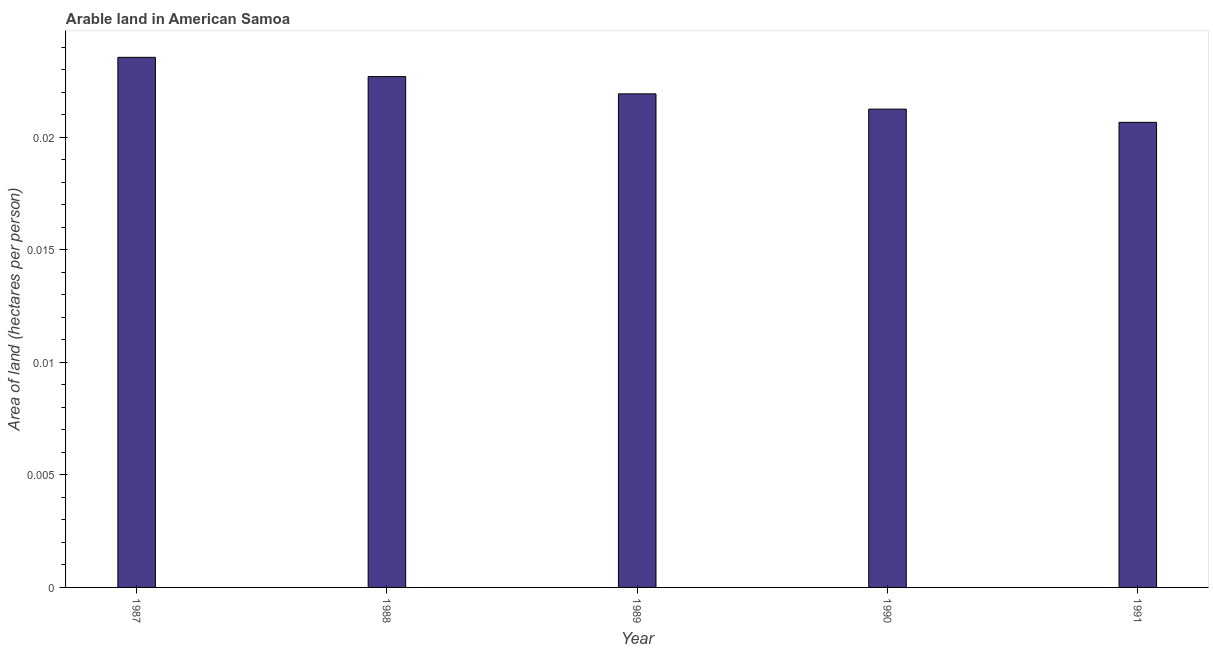What is the title of the graph?
Your answer should be very brief. Arable land in American Samoa. What is the label or title of the Y-axis?
Ensure brevity in your answer.  Area of land (hectares per person). What is the area of arable land in 1987?
Provide a short and direct response. 0.02. Across all years, what is the maximum area of arable land?
Offer a very short reply. 0.02. Across all years, what is the minimum area of arable land?
Give a very brief answer. 0.02. In which year was the area of arable land maximum?
Give a very brief answer. 1987. What is the sum of the area of arable land?
Give a very brief answer. 0.11. What is the average area of arable land per year?
Make the answer very short. 0.02. What is the median area of arable land?
Keep it short and to the point. 0.02. In how many years, is the area of arable land greater than 0.003 hectares per person?
Ensure brevity in your answer.  5. Do a majority of the years between 1987 and 1988 (inclusive) have area of arable land greater than 0.004 hectares per person?
Offer a terse response. Yes. What is the ratio of the area of arable land in 1987 to that in 1988?
Provide a short and direct response. 1.04. Is the area of arable land in 1989 less than that in 1991?
Offer a terse response. No. Is the difference between the area of arable land in 1988 and 1989 greater than the difference between any two years?
Give a very brief answer. No. What is the difference between the highest and the lowest area of arable land?
Provide a succinct answer. 0. How many bars are there?
Offer a very short reply. 5. Are all the bars in the graph horizontal?
Your response must be concise. No. How many years are there in the graph?
Offer a terse response. 5. What is the difference between two consecutive major ticks on the Y-axis?
Your response must be concise. 0.01. What is the Area of land (hectares per person) of 1987?
Keep it short and to the point. 0.02. What is the Area of land (hectares per person) in 1988?
Your answer should be compact. 0.02. What is the Area of land (hectares per person) in 1989?
Give a very brief answer. 0.02. What is the Area of land (hectares per person) of 1990?
Make the answer very short. 0.02. What is the Area of land (hectares per person) of 1991?
Provide a succinct answer. 0.02. What is the difference between the Area of land (hectares per person) in 1987 and 1988?
Offer a terse response. 0. What is the difference between the Area of land (hectares per person) in 1987 and 1989?
Keep it short and to the point. 0. What is the difference between the Area of land (hectares per person) in 1987 and 1990?
Offer a terse response. 0. What is the difference between the Area of land (hectares per person) in 1987 and 1991?
Your answer should be very brief. 0. What is the difference between the Area of land (hectares per person) in 1988 and 1989?
Keep it short and to the point. 0. What is the difference between the Area of land (hectares per person) in 1988 and 1990?
Offer a terse response. 0. What is the difference between the Area of land (hectares per person) in 1988 and 1991?
Provide a succinct answer. 0. What is the difference between the Area of land (hectares per person) in 1989 and 1990?
Make the answer very short. 0. What is the difference between the Area of land (hectares per person) in 1989 and 1991?
Your response must be concise. 0. What is the difference between the Area of land (hectares per person) in 1990 and 1991?
Offer a terse response. 0. What is the ratio of the Area of land (hectares per person) in 1987 to that in 1988?
Ensure brevity in your answer.  1.04. What is the ratio of the Area of land (hectares per person) in 1987 to that in 1989?
Your answer should be compact. 1.07. What is the ratio of the Area of land (hectares per person) in 1987 to that in 1990?
Make the answer very short. 1.11. What is the ratio of the Area of land (hectares per person) in 1987 to that in 1991?
Keep it short and to the point. 1.14. What is the ratio of the Area of land (hectares per person) in 1988 to that in 1989?
Your answer should be compact. 1.03. What is the ratio of the Area of land (hectares per person) in 1988 to that in 1990?
Your answer should be very brief. 1.07. What is the ratio of the Area of land (hectares per person) in 1988 to that in 1991?
Your answer should be very brief. 1.1. What is the ratio of the Area of land (hectares per person) in 1989 to that in 1990?
Offer a very short reply. 1.03. What is the ratio of the Area of land (hectares per person) in 1989 to that in 1991?
Make the answer very short. 1.06. What is the ratio of the Area of land (hectares per person) in 1990 to that in 1991?
Provide a succinct answer. 1.03. 